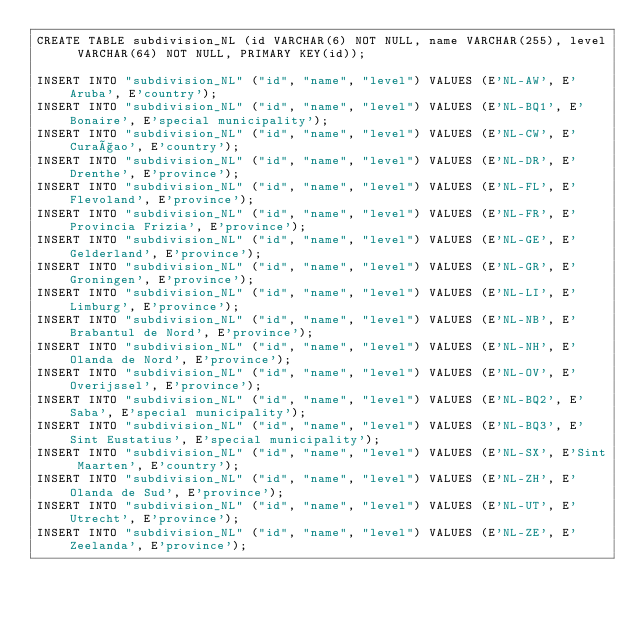Convert code to text. <code><loc_0><loc_0><loc_500><loc_500><_SQL_>CREATE TABLE subdivision_NL (id VARCHAR(6) NOT NULL, name VARCHAR(255), level VARCHAR(64) NOT NULL, PRIMARY KEY(id));

INSERT INTO "subdivision_NL" ("id", "name", "level") VALUES (E'NL-AW', E'Aruba', E'country');
INSERT INTO "subdivision_NL" ("id", "name", "level") VALUES (E'NL-BQ1', E'Bonaire', E'special municipality');
INSERT INTO "subdivision_NL" ("id", "name", "level") VALUES (E'NL-CW', E'Curaçao', E'country');
INSERT INTO "subdivision_NL" ("id", "name", "level") VALUES (E'NL-DR', E'Drenthe', E'province');
INSERT INTO "subdivision_NL" ("id", "name", "level") VALUES (E'NL-FL', E'Flevoland', E'province');
INSERT INTO "subdivision_NL" ("id", "name", "level") VALUES (E'NL-FR', E'Provincia Frizia', E'province');
INSERT INTO "subdivision_NL" ("id", "name", "level") VALUES (E'NL-GE', E'Gelderland', E'province');
INSERT INTO "subdivision_NL" ("id", "name", "level") VALUES (E'NL-GR', E'Groningen', E'province');
INSERT INTO "subdivision_NL" ("id", "name", "level") VALUES (E'NL-LI', E'Limburg', E'province');
INSERT INTO "subdivision_NL" ("id", "name", "level") VALUES (E'NL-NB', E'Brabantul de Nord', E'province');
INSERT INTO "subdivision_NL" ("id", "name", "level") VALUES (E'NL-NH', E'Olanda de Nord', E'province');
INSERT INTO "subdivision_NL" ("id", "name", "level") VALUES (E'NL-OV', E'Overijssel', E'province');
INSERT INTO "subdivision_NL" ("id", "name", "level") VALUES (E'NL-BQ2', E'Saba', E'special municipality');
INSERT INTO "subdivision_NL" ("id", "name", "level") VALUES (E'NL-BQ3', E'Sint Eustatius', E'special municipality');
INSERT INTO "subdivision_NL" ("id", "name", "level") VALUES (E'NL-SX', E'Sint Maarten', E'country');
INSERT INTO "subdivision_NL" ("id", "name", "level") VALUES (E'NL-ZH', E'Olanda de Sud', E'province');
INSERT INTO "subdivision_NL" ("id", "name", "level") VALUES (E'NL-UT', E'Utrecht', E'province');
INSERT INTO "subdivision_NL" ("id", "name", "level") VALUES (E'NL-ZE', E'Zeelanda', E'province');
</code> 